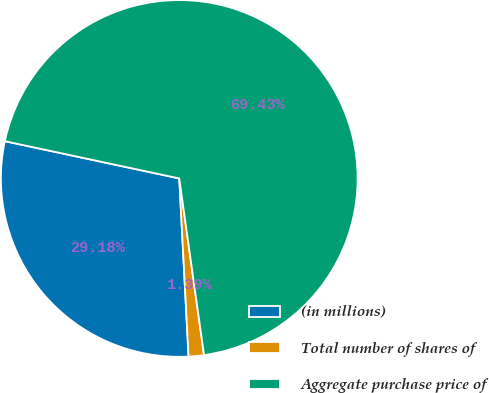Convert chart to OTSL. <chart><loc_0><loc_0><loc_500><loc_500><pie_chart><fcel>(in millions)<fcel>Total number of shares of<fcel>Aggregate purchase price of<nl><fcel>29.18%<fcel>1.39%<fcel>69.43%<nl></chart> 